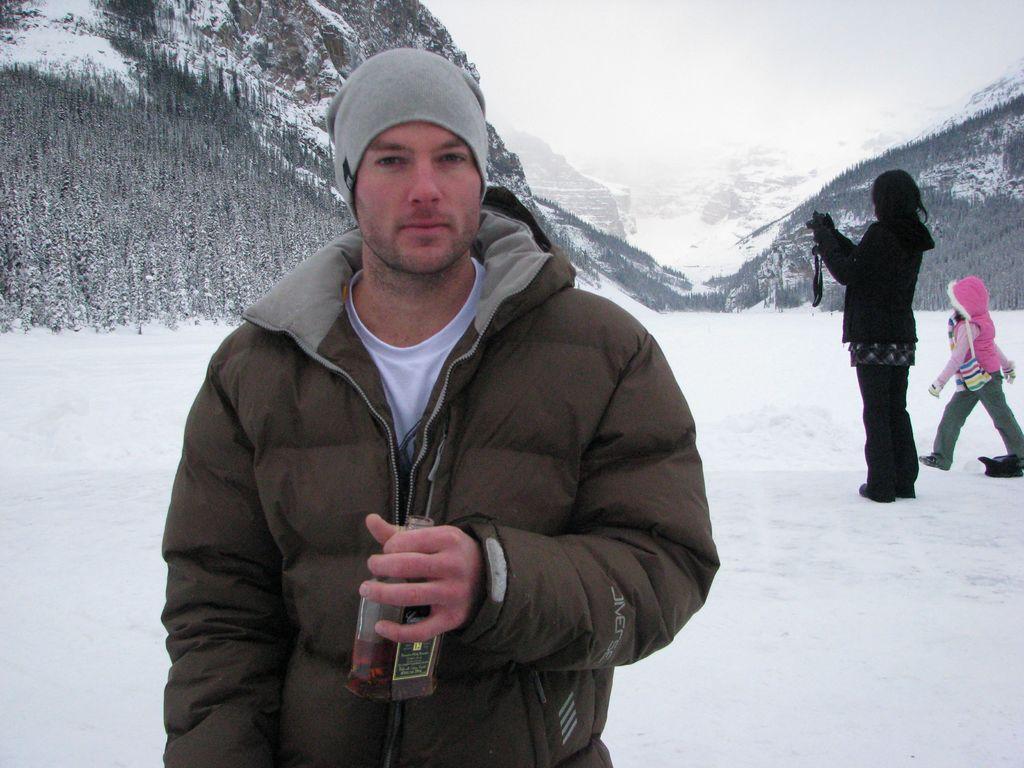Please provide a concise description of this image. In the image we can see a man standing, wearing clothes, cap and holding a bottle in his hand. Behind him we can see a woman and a child standing, wearing clothes and the woman is holding a camera in her hand. Everywhere there is a snow white in color. Here we can see trees and a sky. 